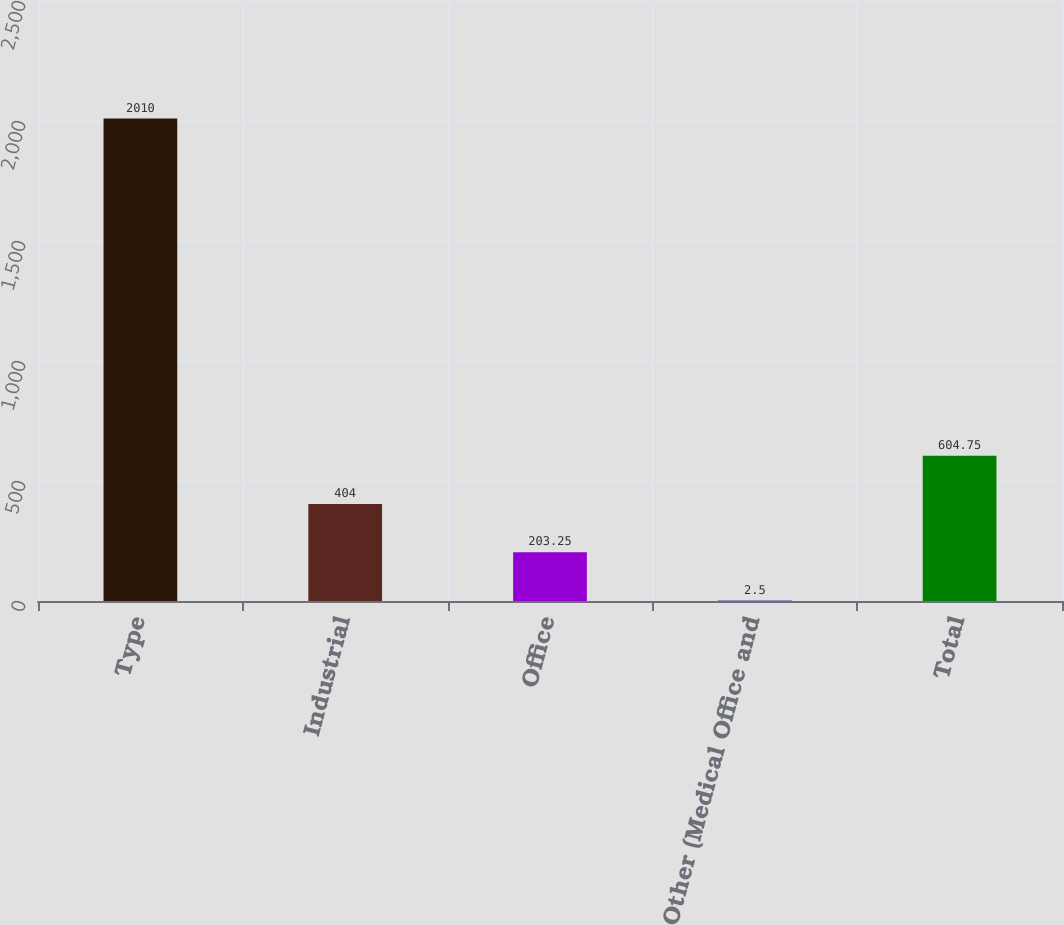<chart> <loc_0><loc_0><loc_500><loc_500><bar_chart><fcel>Type<fcel>Industrial<fcel>Office<fcel>Other (Medical Office and<fcel>Total<nl><fcel>2010<fcel>404<fcel>203.25<fcel>2.5<fcel>604.75<nl></chart> 